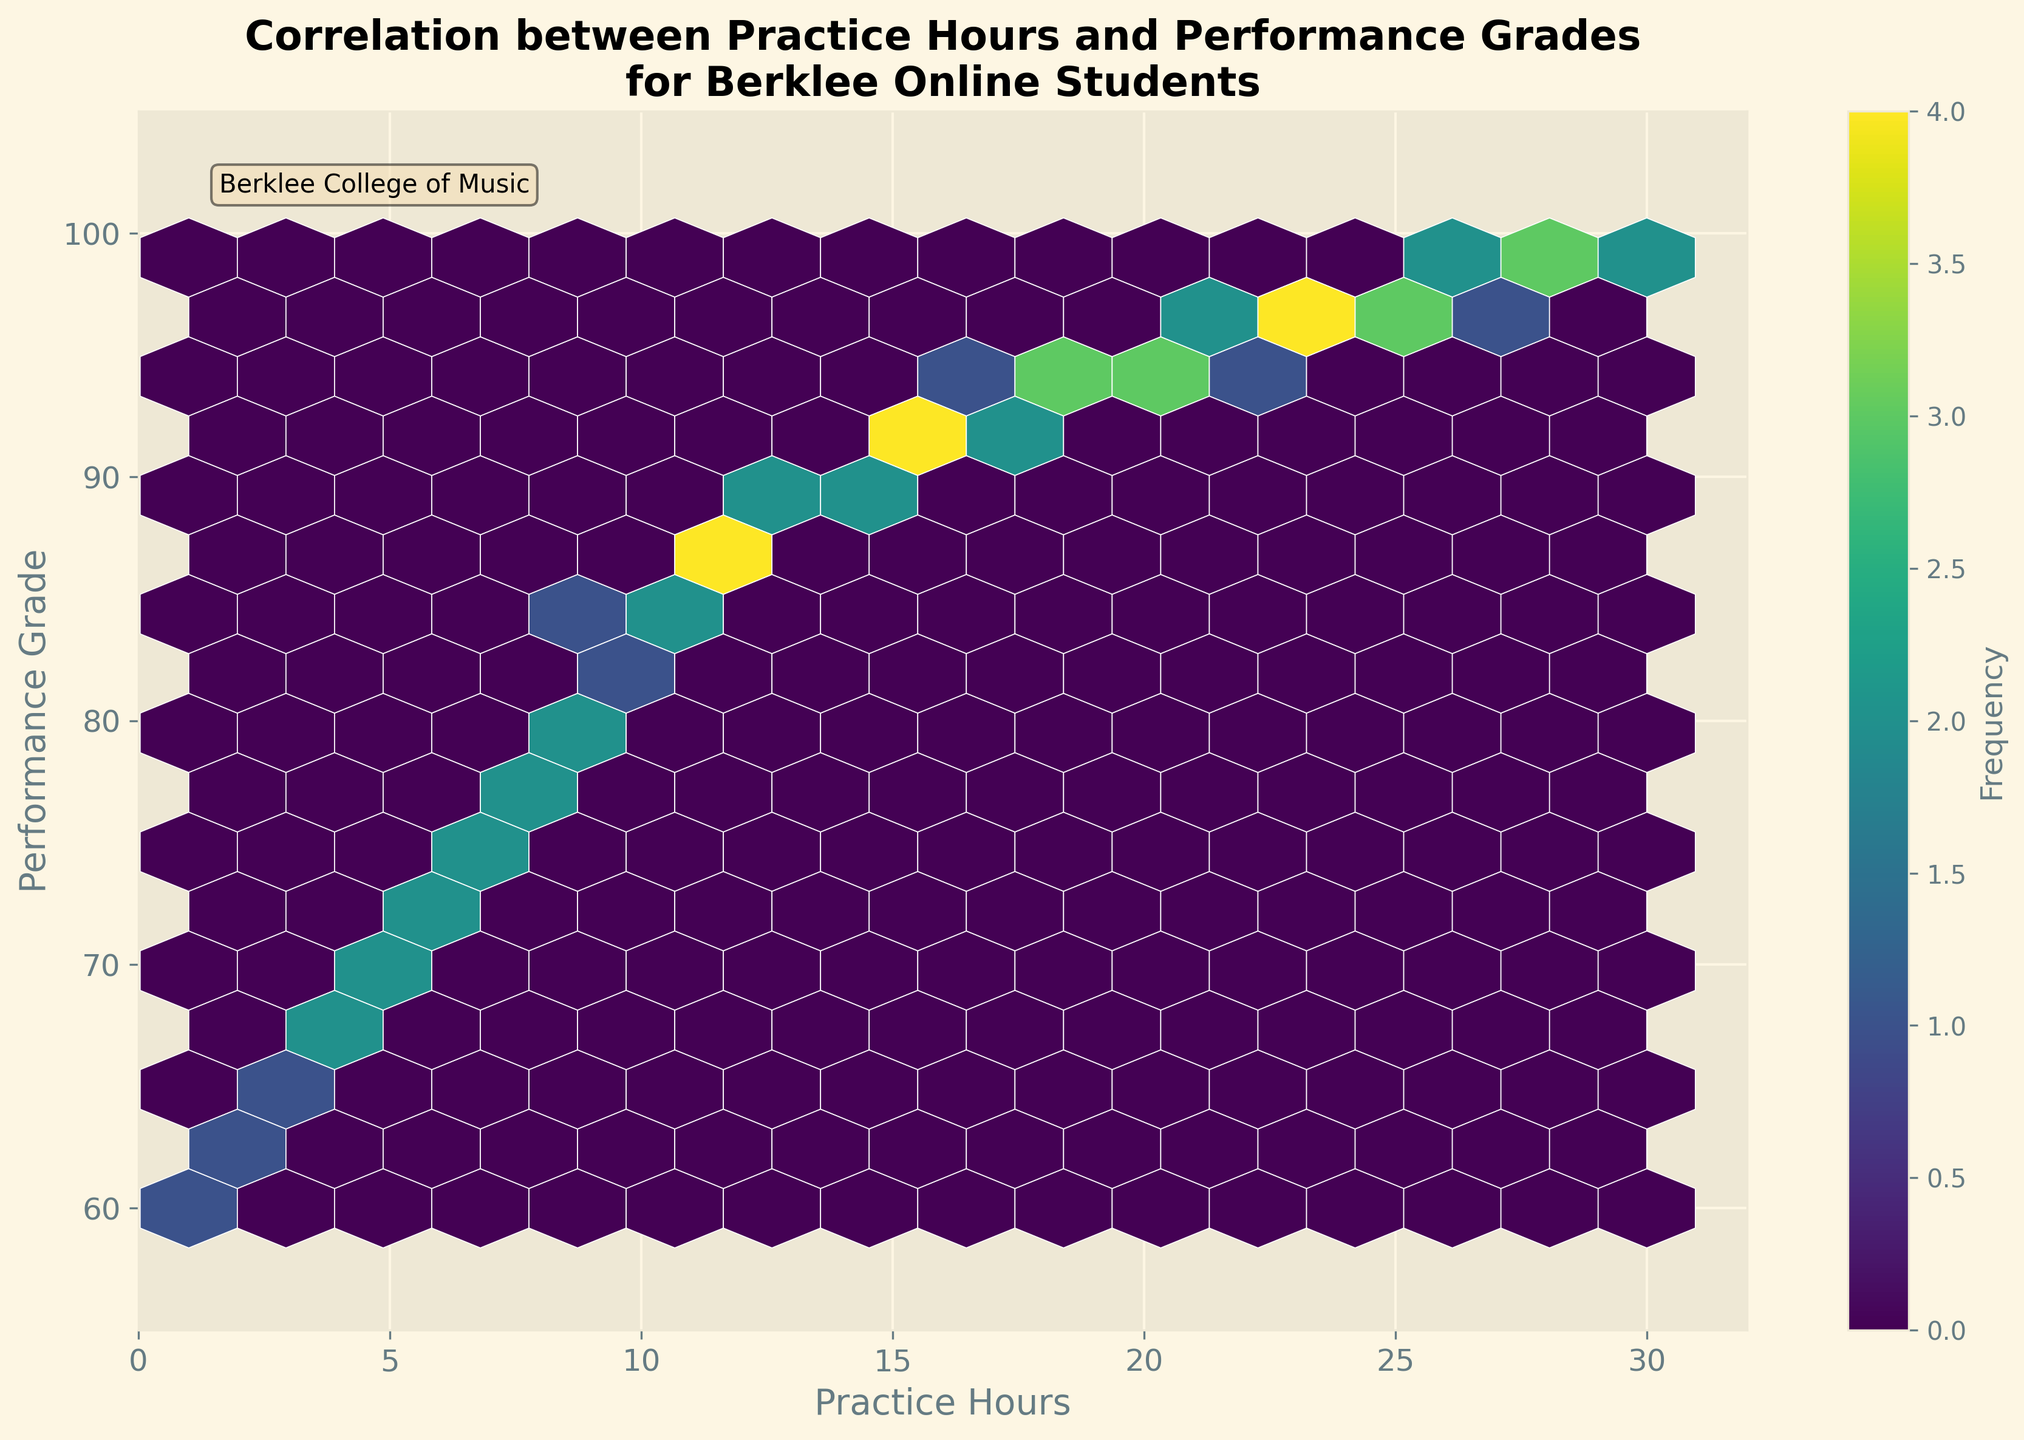What is the title of the figure? The title is prominently displayed at the top of the plot. It reads: "Correlation between Practice Hours and Performance Grades for Berklee Online Students".
Answer: Correlation between Practice Hours and Performance Grades for Berklee Online Students What do the x and y axes represent? The x-axis label is "Practice Hours", and the y-axis label is "Performance Grade". These labels indicate what type of data each axis represents.
Answer: Practice Hours and Performance Grade What is the color of the hexagons? The hexagons are shaded in various tones of a single color, which is determined by the 'viridis' color map. The different shades represent varying frequencies of data points.
Answer: Shades of viridis What does the color bar indicate? The color bar on the right side of the plot indicates the frequency of the data points within each hexagon. Darker colors represent higher frequencies.
Answer: Frequency What is the range of the x-axis? The x-axis ranges from 0 to 32 as shown by its tick marks.
Answer: 0 to 32 What is the general trend visible in this plot? The majority of hexagons show an upward trend from left to right, indicating a positive correlation between practice hours and performance grades.
Answer: Positive correlation Which range of practice hours shows the highest frequency of data points? The darkest hexagons appear around the practice hours range of 28 to 30, indicating the highest frequency of data points in this range.
Answer: 28 to 30 practice hours How does the performance grade change with increasing practice hours? As practice hours increase, performance grades generally trend upwards, suggesting a positive correlation. For example, students with 30 practice hours have grades around 99, while those with fewer hours tend to have lower grades.
Answer: Grades increase What is the performance grade for students who practice 15 hours? To determine this, locate the hexagons around the 15 hours mark on the x-axis. These hexagons correspond to performance grades around 90 to 92.
Answer: 90 to 92 Are there any outliers in the data? At a quick glance, no hexagons clearly stand out from the general trend, indicating there are no significant outliers in the dataset displayed.
Answer: No significant outliers 